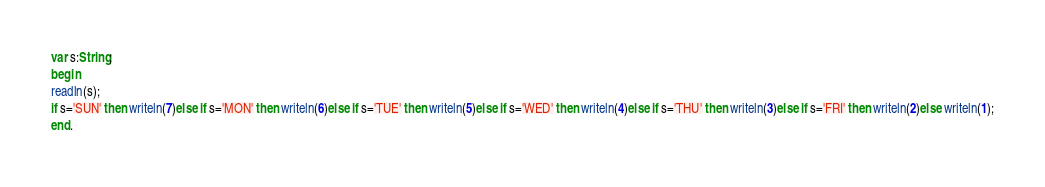Convert code to text. <code><loc_0><loc_0><loc_500><loc_500><_Pascal_>var s:String;
begin
readln(s);
if s='SUN' then writeln(7)else if s='MON' then writeln(6)else if s='TUE' then writeln(5)else if s='WED' then writeln(4)else if s='THU' then writeln(3)else if s='FRI' then writeln(2)else writeln(1);
end.
</code> 